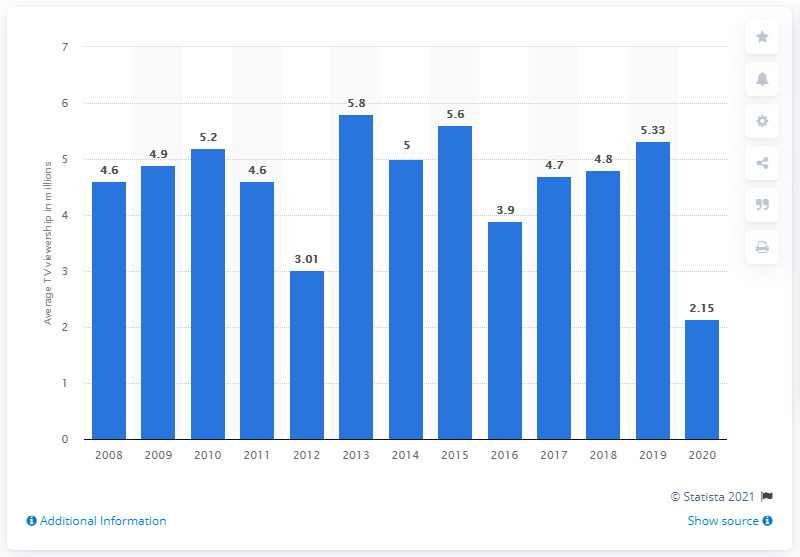Draw attention to some important aspects in this diagram. In 2020, the average TV viewership per game in the United States was 2.15. 